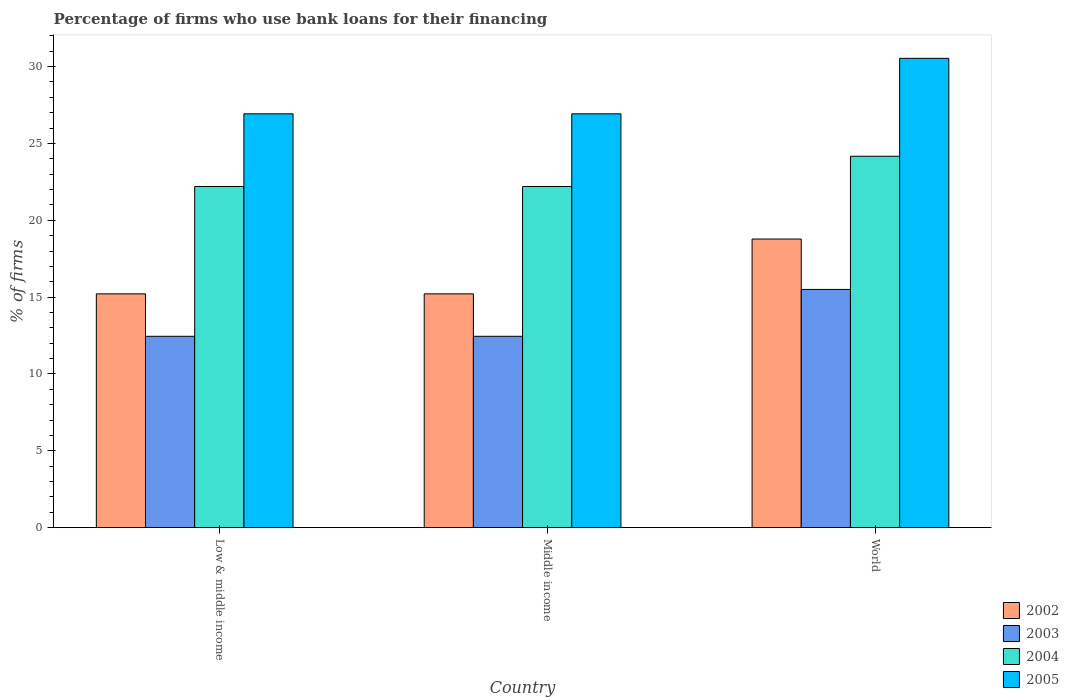Are the number of bars per tick equal to the number of legend labels?
Your response must be concise. Yes. How many bars are there on the 2nd tick from the left?
Give a very brief answer. 4. How many bars are there on the 3rd tick from the right?
Offer a very short reply. 4. What is the percentage of firms who use bank loans for their financing in 2002 in Middle income?
Make the answer very short. 15.21. Across all countries, what is the maximum percentage of firms who use bank loans for their financing in 2004?
Your answer should be compact. 24.17. Across all countries, what is the minimum percentage of firms who use bank loans for their financing in 2003?
Your response must be concise. 12.45. In which country was the percentage of firms who use bank loans for their financing in 2005 maximum?
Your answer should be compact. World. What is the total percentage of firms who use bank loans for their financing in 2005 in the graph?
Make the answer very short. 84.39. What is the difference between the percentage of firms who use bank loans for their financing in 2003 in Low & middle income and that in Middle income?
Give a very brief answer. 0. What is the difference between the percentage of firms who use bank loans for their financing in 2002 in Middle income and the percentage of firms who use bank loans for their financing in 2003 in World?
Provide a succinct answer. -0.29. What is the average percentage of firms who use bank loans for their financing in 2005 per country?
Offer a very short reply. 28.13. What is the difference between the percentage of firms who use bank loans for their financing of/in 2002 and percentage of firms who use bank loans for their financing of/in 2005 in Middle income?
Your answer should be very brief. -11.72. What is the ratio of the percentage of firms who use bank loans for their financing in 2003 in Middle income to that in World?
Make the answer very short. 0.8. Is the difference between the percentage of firms who use bank loans for their financing in 2002 in Low & middle income and World greater than the difference between the percentage of firms who use bank loans for their financing in 2005 in Low & middle income and World?
Provide a short and direct response. Yes. What is the difference between the highest and the second highest percentage of firms who use bank loans for their financing in 2003?
Provide a short and direct response. -3.05. What is the difference between the highest and the lowest percentage of firms who use bank loans for their financing in 2004?
Provide a short and direct response. 1.97. Is the sum of the percentage of firms who use bank loans for their financing in 2005 in Low & middle income and World greater than the maximum percentage of firms who use bank loans for their financing in 2002 across all countries?
Provide a short and direct response. Yes. How many bars are there?
Your answer should be compact. 12. Are all the bars in the graph horizontal?
Ensure brevity in your answer.  No. Are the values on the major ticks of Y-axis written in scientific E-notation?
Keep it short and to the point. No. Where does the legend appear in the graph?
Offer a terse response. Bottom right. What is the title of the graph?
Your response must be concise. Percentage of firms who use bank loans for their financing. Does "1989" appear as one of the legend labels in the graph?
Provide a succinct answer. No. What is the label or title of the X-axis?
Provide a succinct answer. Country. What is the label or title of the Y-axis?
Give a very brief answer. % of firms. What is the % of firms of 2002 in Low & middle income?
Offer a terse response. 15.21. What is the % of firms in 2003 in Low & middle income?
Provide a short and direct response. 12.45. What is the % of firms of 2004 in Low & middle income?
Make the answer very short. 22.2. What is the % of firms in 2005 in Low & middle income?
Provide a succinct answer. 26.93. What is the % of firms of 2002 in Middle income?
Give a very brief answer. 15.21. What is the % of firms in 2003 in Middle income?
Ensure brevity in your answer.  12.45. What is the % of firms in 2004 in Middle income?
Keep it short and to the point. 22.2. What is the % of firms in 2005 in Middle income?
Your answer should be compact. 26.93. What is the % of firms in 2002 in World?
Offer a terse response. 18.78. What is the % of firms of 2003 in World?
Keep it short and to the point. 15.5. What is the % of firms of 2004 in World?
Your response must be concise. 24.17. What is the % of firms of 2005 in World?
Make the answer very short. 30.54. Across all countries, what is the maximum % of firms in 2002?
Your answer should be very brief. 18.78. Across all countries, what is the maximum % of firms in 2004?
Offer a very short reply. 24.17. Across all countries, what is the maximum % of firms of 2005?
Give a very brief answer. 30.54. Across all countries, what is the minimum % of firms of 2002?
Keep it short and to the point. 15.21. Across all countries, what is the minimum % of firms of 2003?
Provide a succinct answer. 12.45. Across all countries, what is the minimum % of firms in 2005?
Offer a terse response. 26.93. What is the total % of firms in 2002 in the graph?
Offer a very short reply. 49.21. What is the total % of firms of 2003 in the graph?
Provide a short and direct response. 40.4. What is the total % of firms in 2004 in the graph?
Your answer should be compact. 68.57. What is the total % of firms of 2005 in the graph?
Keep it short and to the point. 84.39. What is the difference between the % of firms in 2002 in Low & middle income and that in Middle income?
Your answer should be very brief. 0. What is the difference between the % of firms of 2004 in Low & middle income and that in Middle income?
Keep it short and to the point. 0. What is the difference between the % of firms in 2002 in Low & middle income and that in World?
Provide a succinct answer. -3.57. What is the difference between the % of firms in 2003 in Low & middle income and that in World?
Your response must be concise. -3.05. What is the difference between the % of firms of 2004 in Low & middle income and that in World?
Your answer should be compact. -1.97. What is the difference between the % of firms in 2005 in Low & middle income and that in World?
Make the answer very short. -3.61. What is the difference between the % of firms of 2002 in Middle income and that in World?
Give a very brief answer. -3.57. What is the difference between the % of firms of 2003 in Middle income and that in World?
Make the answer very short. -3.05. What is the difference between the % of firms of 2004 in Middle income and that in World?
Your answer should be very brief. -1.97. What is the difference between the % of firms in 2005 in Middle income and that in World?
Provide a succinct answer. -3.61. What is the difference between the % of firms in 2002 in Low & middle income and the % of firms in 2003 in Middle income?
Offer a very short reply. 2.76. What is the difference between the % of firms in 2002 in Low & middle income and the % of firms in 2004 in Middle income?
Offer a very short reply. -6.99. What is the difference between the % of firms in 2002 in Low & middle income and the % of firms in 2005 in Middle income?
Your response must be concise. -11.72. What is the difference between the % of firms of 2003 in Low & middle income and the % of firms of 2004 in Middle income?
Your answer should be very brief. -9.75. What is the difference between the % of firms in 2003 in Low & middle income and the % of firms in 2005 in Middle income?
Offer a terse response. -14.48. What is the difference between the % of firms of 2004 in Low & middle income and the % of firms of 2005 in Middle income?
Your response must be concise. -4.73. What is the difference between the % of firms in 2002 in Low & middle income and the % of firms in 2003 in World?
Give a very brief answer. -0.29. What is the difference between the % of firms of 2002 in Low & middle income and the % of firms of 2004 in World?
Offer a terse response. -8.95. What is the difference between the % of firms in 2002 in Low & middle income and the % of firms in 2005 in World?
Your answer should be compact. -15.33. What is the difference between the % of firms of 2003 in Low & middle income and the % of firms of 2004 in World?
Provide a succinct answer. -11.72. What is the difference between the % of firms in 2003 in Low & middle income and the % of firms in 2005 in World?
Provide a succinct answer. -18.09. What is the difference between the % of firms of 2004 in Low & middle income and the % of firms of 2005 in World?
Keep it short and to the point. -8.34. What is the difference between the % of firms in 2002 in Middle income and the % of firms in 2003 in World?
Provide a succinct answer. -0.29. What is the difference between the % of firms in 2002 in Middle income and the % of firms in 2004 in World?
Your answer should be very brief. -8.95. What is the difference between the % of firms in 2002 in Middle income and the % of firms in 2005 in World?
Make the answer very short. -15.33. What is the difference between the % of firms of 2003 in Middle income and the % of firms of 2004 in World?
Ensure brevity in your answer.  -11.72. What is the difference between the % of firms of 2003 in Middle income and the % of firms of 2005 in World?
Provide a succinct answer. -18.09. What is the difference between the % of firms in 2004 in Middle income and the % of firms in 2005 in World?
Give a very brief answer. -8.34. What is the average % of firms of 2002 per country?
Your response must be concise. 16.4. What is the average % of firms of 2003 per country?
Make the answer very short. 13.47. What is the average % of firms in 2004 per country?
Your answer should be very brief. 22.86. What is the average % of firms of 2005 per country?
Offer a terse response. 28.13. What is the difference between the % of firms of 2002 and % of firms of 2003 in Low & middle income?
Give a very brief answer. 2.76. What is the difference between the % of firms in 2002 and % of firms in 2004 in Low & middle income?
Provide a succinct answer. -6.99. What is the difference between the % of firms of 2002 and % of firms of 2005 in Low & middle income?
Ensure brevity in your answer.  -11.72. What is the difference between the % of firms in 2003 and % of firms in 2004 in Low & middle income?
Your answer should be very brief. -9.75. What is the difference between the % of firms in 2003 and % of firms in 2005 in Low & middle income?
Offer a terse response. -14.48. What is the difference between the % of firms of 2004 and % of firms of 2005 in Low & middle income?
Offer a very short reply. -4.73. What is the difference between the % of firms in 2002 and % of firms in 2003 in Middle income?
Provide a succinct answer. 2.76. What is the difference between the % of firms of 2002 and % of firms of 2004 in Middle income?
Your answer should be compact. -6.99. What is the difference between the % of firms in 2002 and % of firms in 2005 in Middle income?
Keep it short and to the point. -11.72. What is the difference between the % of firms of 2003 and % of firms of 2004 in Middle income?
Your response must be concise. -9.75. What is the difference between the % of firms in 2003 and % of firms in 2005 in Middle income?
Keep it short and to the point. -14.48. What is the difference between the % of firms in 2004 and % of firms in 2005 in Middle income?
Make the answer very short. -4.73. What is the difference between the % of firms of 2002 and % of firms of 2003 in World?
Make the answer very short. 3.28. What is the difference between the % of firms of 2002 and % of firms of 2004 in World?
Your response must be concise. -5.39. What is the difference between the % of firms of 2002 and % of firms of 2005 in World?
Your answer should be compact. -11.76. What is the difference between the % of firms of 2003 and % of firms of 2004 in World?
Give a very brief answer. -8.67. What is the difference between the % of firms of 2003 and % of firms of 2005 in World?
Offer a terse response. -15.04. What is the difference between the % of firms of 2004 and % of firms of 2005 in World?
Give a very brief answer. -6.37. What is the ratio of the % of firms in 2002 in Low & middle income to that in Middle income?
Offer a terse response. 1. What is the ratio of the % of firms of 2005 in Low & middle income to that in Middle income?
Provide a succinct answer. 1. What is the ratio of the % of firms in 2002 in Low & middle income to that in World?
Ensure brevity in your answer.  0.81. What is the ratio of the % of firms of 2003 in Low & middle income to that in World?
Provide a succinct answer. 0.8. What is the ratio of the % of firms in 2004 in Low & middle income to that in World?
Ensure brevity in your answer.  0.92. What is the ratio of the % of firms of 2005 in Low & middle income to that in World?
Provide a short and direct response. 0.88. What is the ratio of the % of firms in 2002 in Middle income to that in World?
Give a very brief answer. 0.81. What is the ratio of the % of firms in 2003 in Middle income to that in World?
Give a very brief answer. 0.8. What is the ratio of the % of firms of 2004 in Middle income to that in World?
Make the answer very short. 0.92. What is the ratio of the % of firms of 2005 in Middle income to that in World?
Your answer should be compact. 0.88. What is the difference between the highest and the second highest % of firms of 2002?
Your answer should be compact. 3.57. What is the difference between the highest and the second highest % of firms of 2003?
Keep it short and to the point. 3.05. What is the difference between the highest and the second highest % of firms of 2004?
Provide a succinct answer. 1.97. What is the difference between the highest and the second highest % of firms in 2005?
Make the answer very short. 3.61. What is the difference between the highest and the lowest % of firms of 2002?
Your answer should be compact. 3.57. What is the difference between the highest and the lowest % of firms in 2003?
Ensure brevity in your answer.  3.05. What is the difference between the highest and the lowest % of firms in 2004?
Ensure brevity in your answer.  1.97. What is the difference between the highest and the lowest % of firms in 2005?
Your response must be concise. 3.61. 